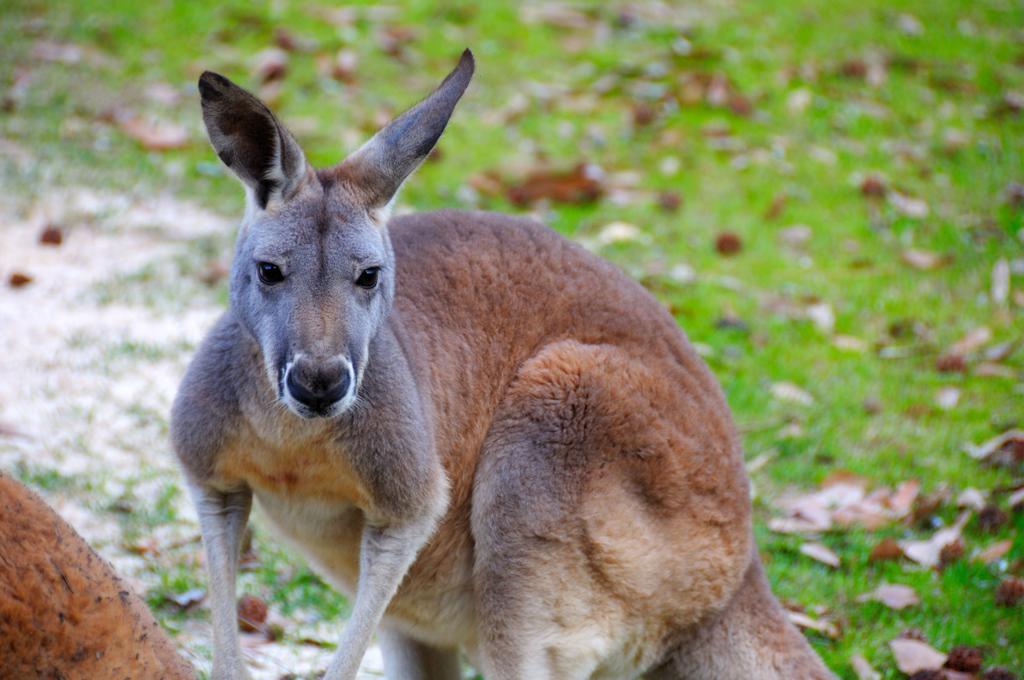Describe this image in one or two sentences. In this picture, we see a kangaroo. In the left bottom, we see an object in brown color. Behind that, we see the grass and small stones. In the background, we see the grass and the dry leaves. This picture is blurred in the background. 